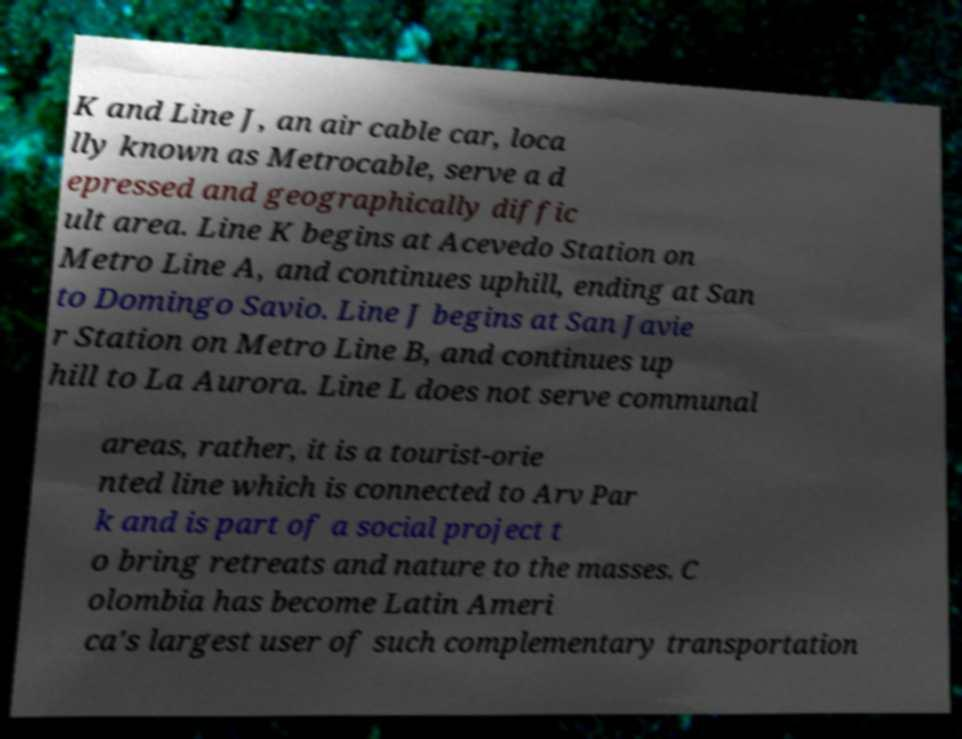There's text embedded in this image that I need extracted. Can you transcribe it verbatim? K and Line J, an air cable car, loca lly known as Metrocable, serve a d epressed and geographically diffic ult area. Line K begins at Acevedo Station on Metro Line A, and continues uphill, ending at San to Domingo Savio. Line J begins at San Javie r Station on Metro Line B, and continues up hill to La Aurora. Line L does not serve communal areas, rather, it is a tourist-orie nted line which is connected to Arv Par k and is part of a social project t o bring retreats and nature to the masses. C olombia has become Latin Ameri ca's largest user of such complementary transportation 